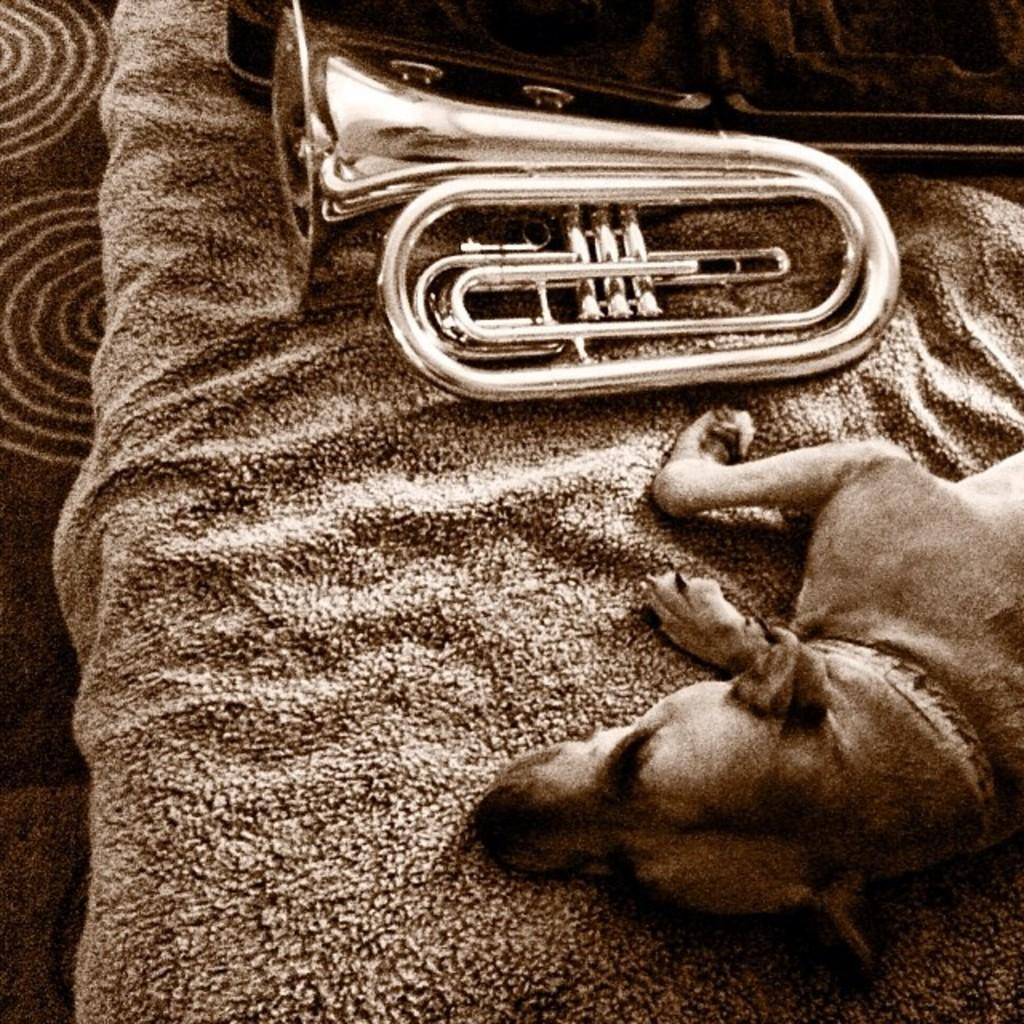What type of animal can be seen in the image? There is a dog in the image. What other object is present in the image besides the dog? There is a musical instrument in the image. How is the musical instrument positioned in the image? The musical instrument is on a cloth. What is the color scheme of the image? The image is in black and white. Can you read the letter that the dog is holding in the image? There is no letter present in the image, and the dog is not holding anything. What type of waste is visible in the image? There is no waste visible in the image; it features a dog and a musical instrument on a cloth. 